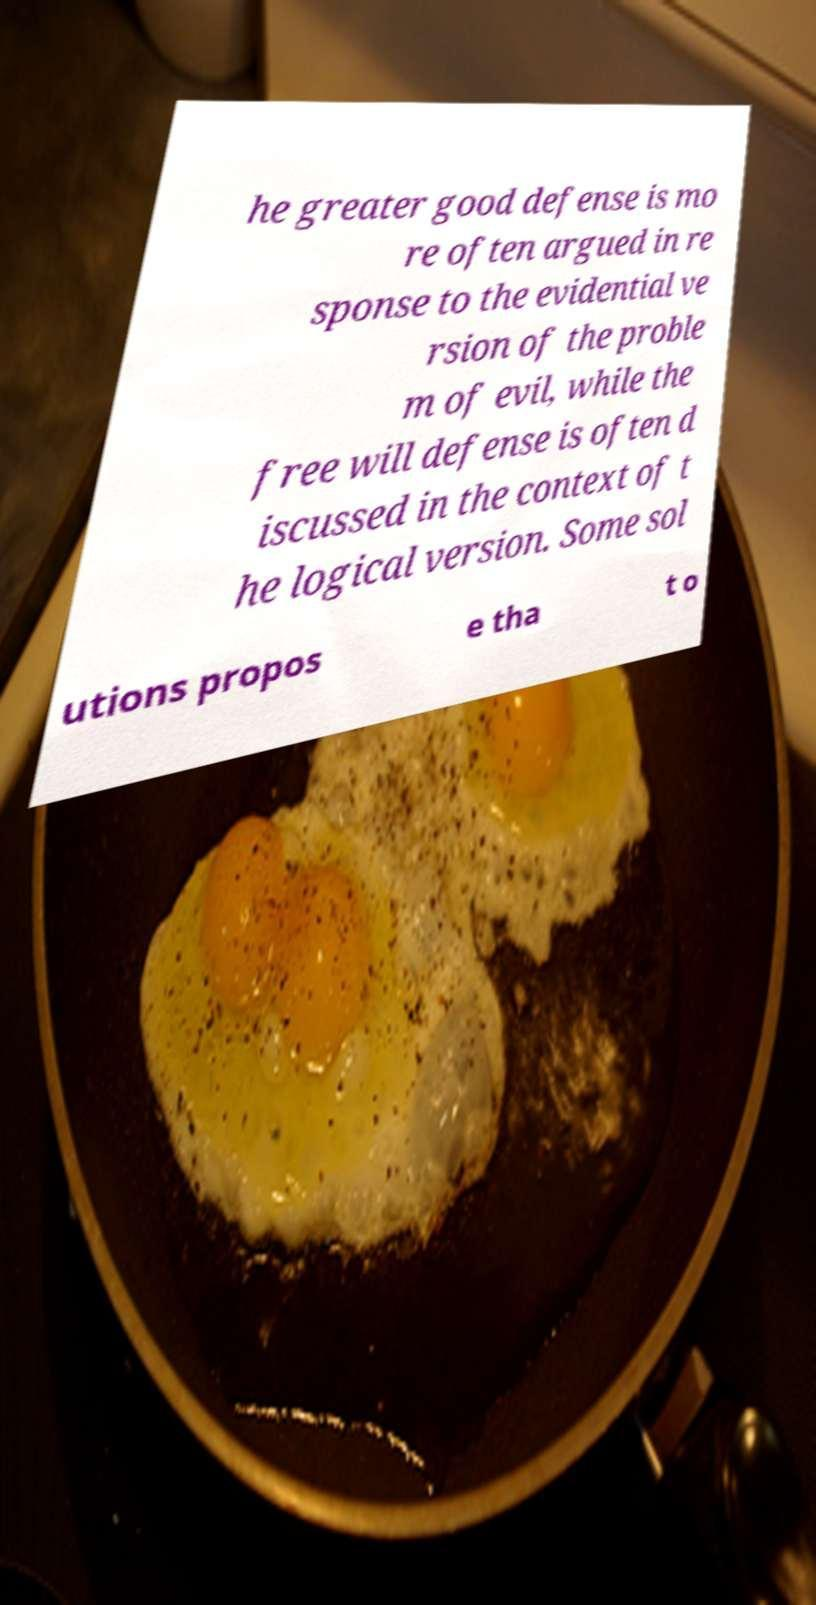For documentation purposes, I need the text within this image transcribed. Could you provide that? he greater good defense is mo re often argued in re sponse to the evidential ve rsion of the proble m of evil, while the free will defense is often d iscussed in the context of t he logical version. Some sol utions propos e tha t o 